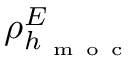<formula> <loc_0><loc_0><loc_500><loc_500>\rho _ { h _ { m o c } } ^ { E }</formula> 